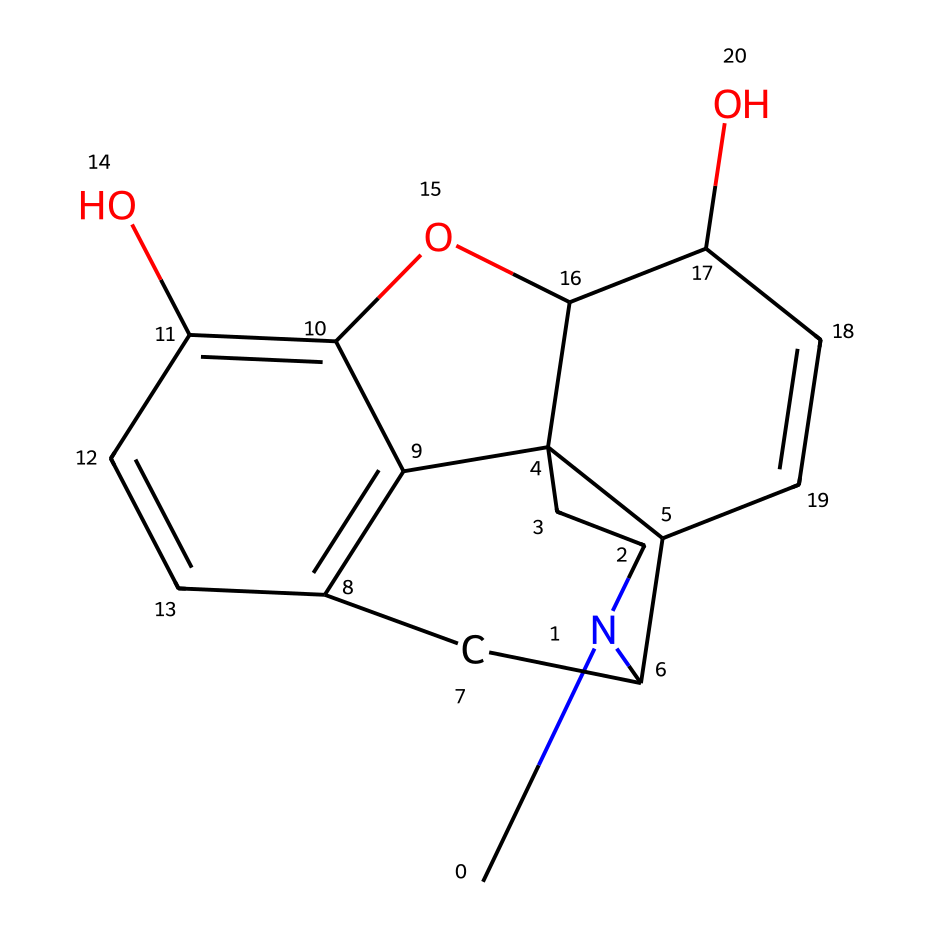What is the molecular formula of morphine? To derive the molecular formula from the SMILES representation, we need to identify the elements and their quantities present in the structure. From the SMILES, we recognize the presence of carbon (C), hydrogen (H), nitrogen (N), and oxygen (O). Counting the atoms gives us: C=17, H=19, N=1, O=2. Thus, the molecular formula is C17H19N1O2.
Answer: C17H19N1O2 How many rings are present in the structure of morphine? Examining the SMILES representation reveals multiple components that indicate ring structures. By analyzing the numbers within the SMILES (the digits indicate the start and end of rings), we identify that morphine contains five rings formed between those numbers. Therefore, there are five rings in the structure.
Answer: 5 Which part of this chemical structure is responsible for its analgesic properties? The nitrogen atom found in the structure of morphine (specifically in the piperidine ring) plays a critical role in its pharmacological activity. It facilitates binding to opioid receptors in the body, which is essential for its pain-relieving effects. Therefore, the nitrogen atom is responsible for the analgesic properties of morphine.
Answer: nitrogen How many chiral centers can be found in morphine? By inspecting the structure closely for asymmetry, we can identify chiral centers where four different substituents are attached to a carbon atom. In the case of morphine, there are four chiral centers present. This ensures that morphine can exist in multiple stereoisomeric forms, adding to its complexity.
Answer: 4 What type of chemical compound is morphine classified as? Morphine is classified as an alkaloid, which are organic compounds that contain basic nitrogen atoms. Alkaloids often exhibit significant pharmacological activities, including those utilized in pain management as exhibited in this case with morphine.
Answer: alkaloid 